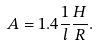<formula> <loc_0><loc_0><loc_500><loc_500>A = 1 . 4 \frac { 1 } { l } \frac { H } { R } .</formula> 